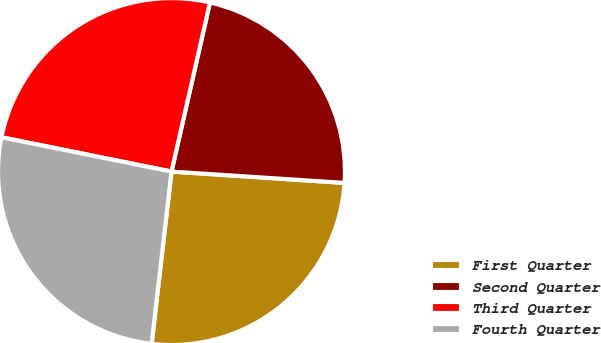Convert chart. <chart><loc_0><loc_0><loc_500><loc_500><pie_chart><fcel>First Quarter<fcel>Second Quarter<fcel>Third Quarter<fcel>Fourth Quarter<nl><fcel>25.78%<fcel>22.48%<fcel>25.39%<fcel>26.34%<nl></chart> 